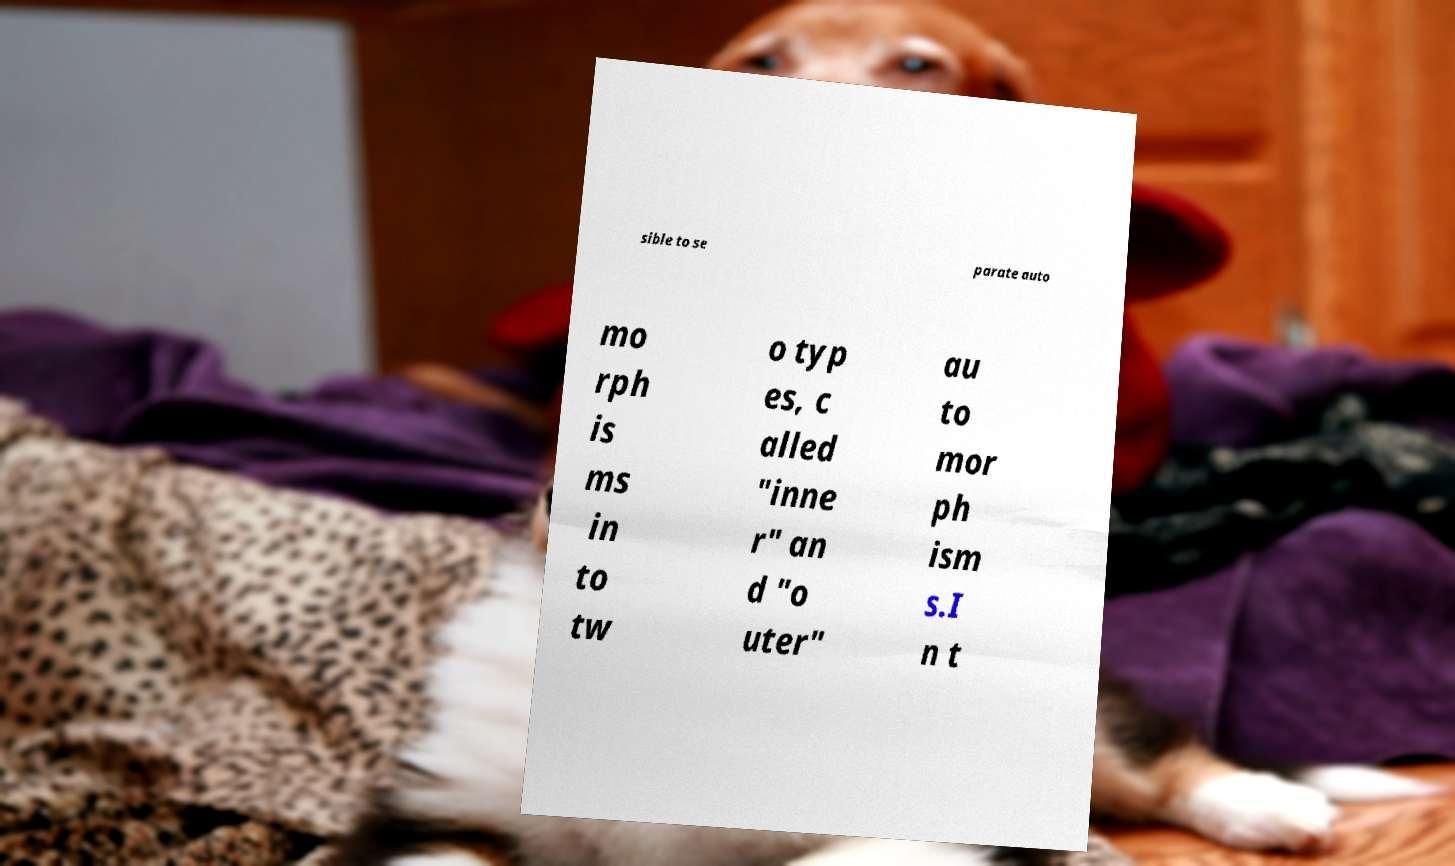Could you assist in decoding the text presented in this image and type it out clearly? sible to se parate auto mo rph is ms in to tw o typ es, c alled "inne r" an d "o uter" au to mor ph ism s.I n t 